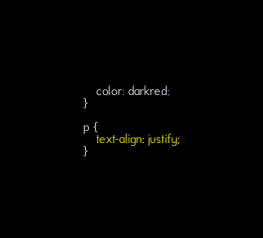Convert code to text. <code><loc_0><loc_0><loc_500><loc_500><_CSS_>    color: darkred;
}

p {
    text-align: justify;
}</code> 